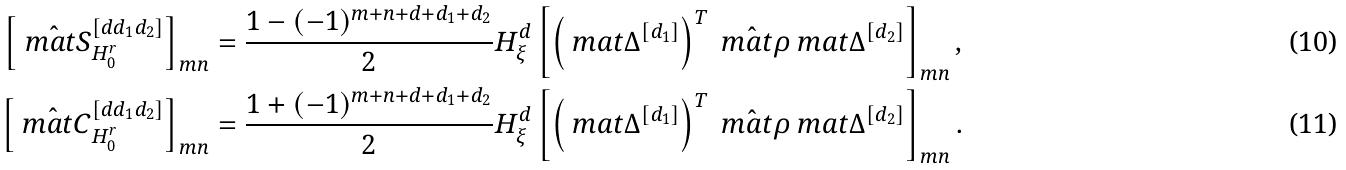<formula> <loc_0><loc_0><loc_500><loc_500>\left [ \hat { \ m a t { S } } ^ { [ d d _ { 1 } d _ { 2 } ] } _ { H ^ { r } _ { 0 } } \right ] _ { m n } & = \frac { 1 - ( - 1 ) ^ { m + n + d + d _ { 1 } + d _ { 2 } } } { 2 } H ^ { d } _ { \xi } \left [ \left ( \ m a t { \Delta } ^ { [ d _ { 1 } ] } \right ) ^ { T } \hat { \ m a t { \rho } } \ m a t { \Delta } ^ { [ d _ { 2 } ] } \right ] _ { m n } , \\ \left [ \hat { \ m a t { C } } ^ { [ d d _ { 1 } d _ { 2 } ] } _ { H ^ { r } _ { 0 } } \right ] _ { m n } & = \frac { 1 + ( - 1 ) ^ { m + n + d + d _ { 1 } + d _ { 2 } } } { 2 } H ^ { d } _ { \xi } \left [ \left ( \ m a t { \Delta } ^ { [ d _ { 1 } ] } \right ) ^ { T } \hat { \ m a t { \rho } } \ m a t { \Delta } ^ { [ d _ { 2 } ] } \right ] _ { m n } .</formula> 